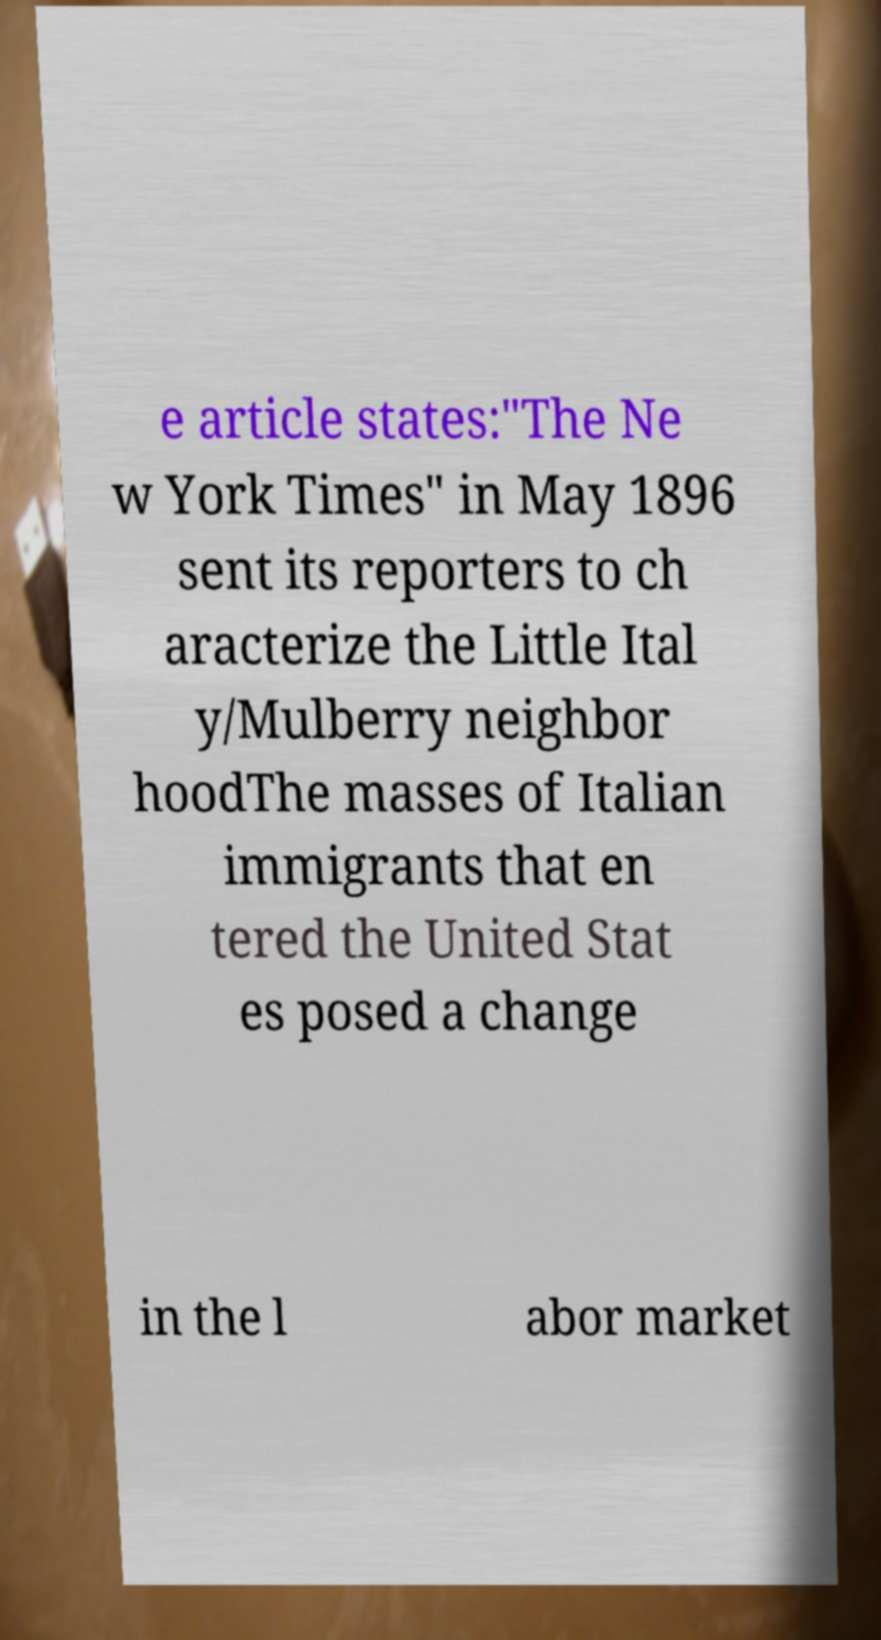Please read and relay the text visible in this image. What does it say? e article states:"The Ne w York Times" in May 1896 sent its reporters to ch aracterize the Little Ital y/Mulberry neighbor hoodThe masses of Italian immigrants that en tered the United Stat es posed a change in the l abor market 